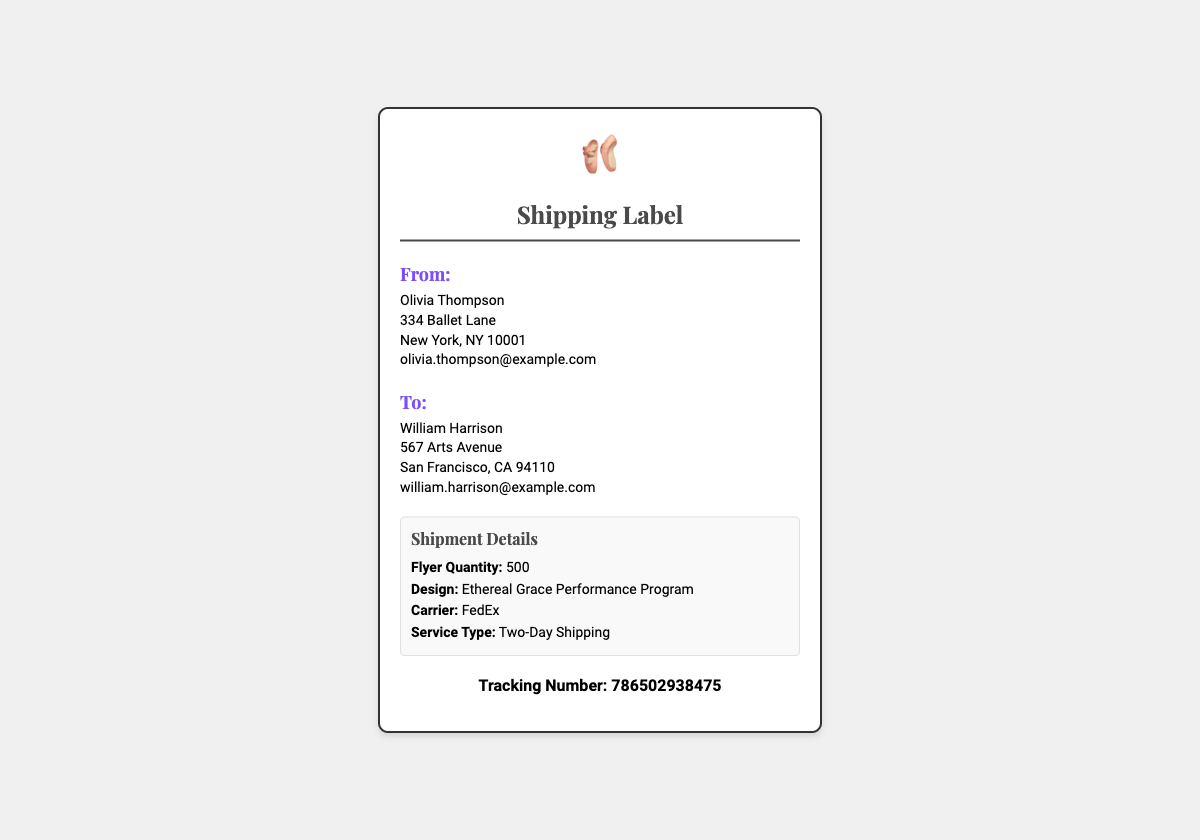What is the sender's name? The sender's name is prominently displayed in the address section of the document.
Answer: Olivia Thompson What is the recipient's email address? The recipient's email is listed under their address information in the document.
Answer: william.harrison@example.com How many flyers are being shipped? The quantity of flyers shipped is specified in the shipment details section.
Answer: 500 What is the name of the design? The design name is mentioned clearly in the shipment details.
Answer: Ethereal Grace Performance Program What shipping service is used? The shipping service type is explicitly noted in the shipment details.
Answer: Two-Day Shipping What city is the sender located in? The sender's city is found in the address section of the document.
Answer: New York What is the tracking number? The tracking number is provided in a dedicated section within the document.
Answer: 786502938475 Which carrier is used for shipping? The carrier name is stated in the shipment details section.
Answer: FedEx What is the address of the recipient? The recipient's address contains the full location information provided in the document.
Answer: 567 Arts Avenue, San Francisco, CA 94110 